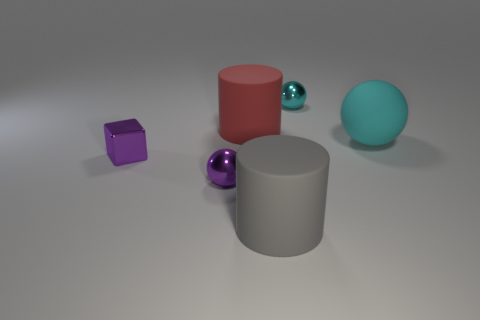Add 1 large cyan spheres. How many objects exist? 7 Subtract all cylinders. How many objects are left? 4 Subtract all small red metal things. Subtract all gray matte things. How many objects are left? 5 Add 2 small metallic cubes. How many small metallic cubes are left? 3 Add 1 large cyan matte spheres. How many large cyan matte spheres exist? 2 Subtract 0 yellow balls. How many objects are left? 6 